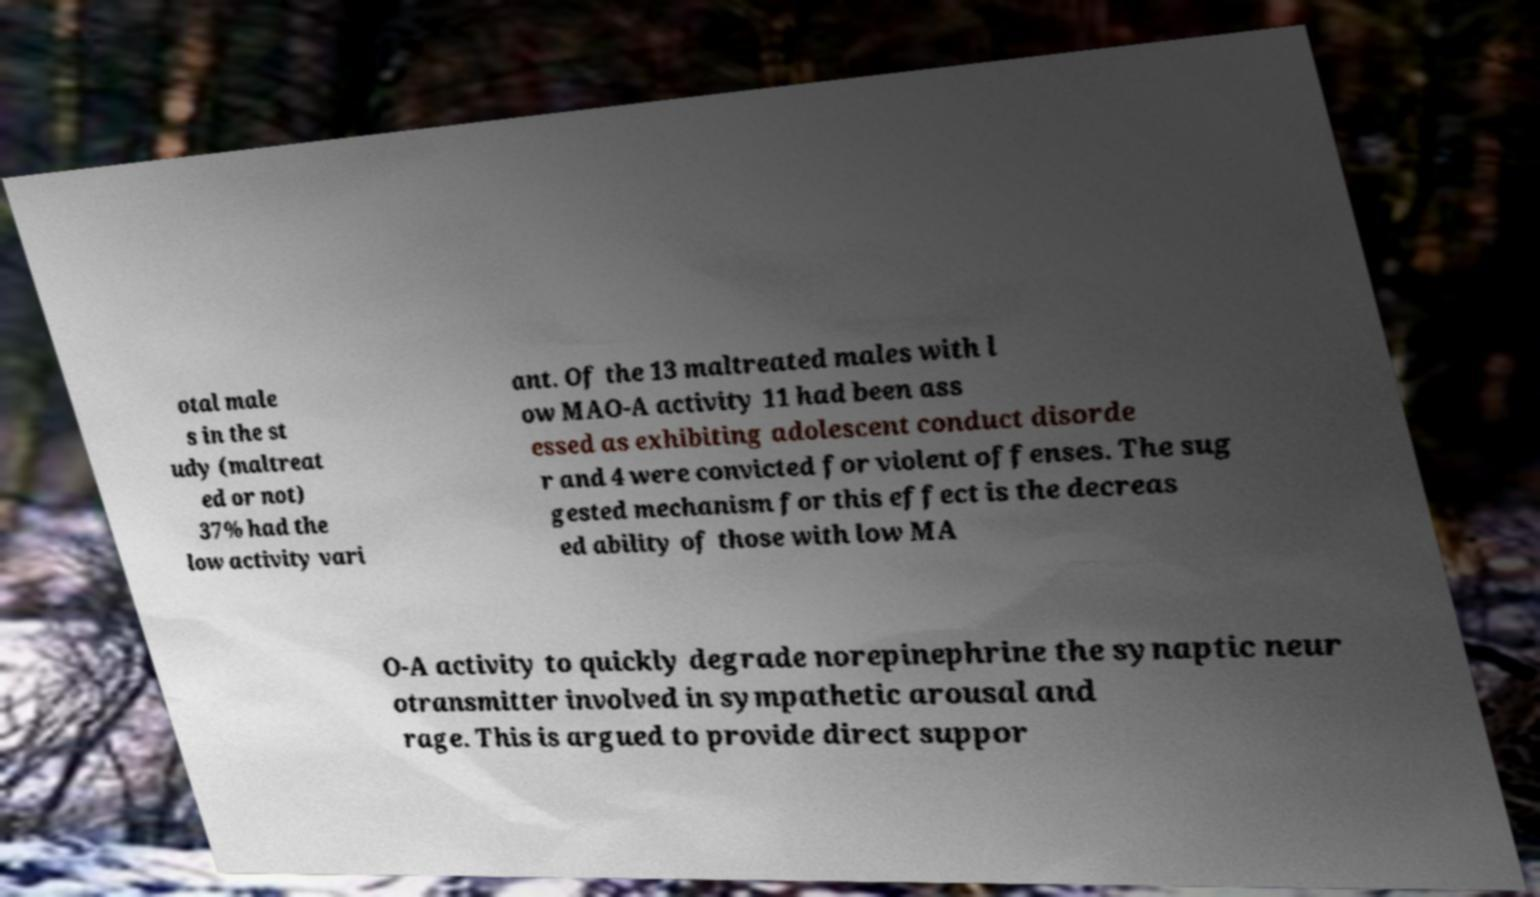Can you read and provide the text displayed in the image?This photo seems to have some interesting text. Can you extract and type it out for me? otal male s in the st udy (maltreat ed or not) 37% had the low activity vari ant. Of the 13 maltreated males with l ow MAO-A activity 11 had been ass essed as exhibiting adolescent conduct disorde r and 4 were convicted for violent offenses. The sug gested mechanism for this effect is the decreas ed ability of those with low MA O-A activity to quickly degrade norepinephrine the synaptic neur otransmitter involved in sympathetic arousal and rage. This is argued to provide direct suppor 